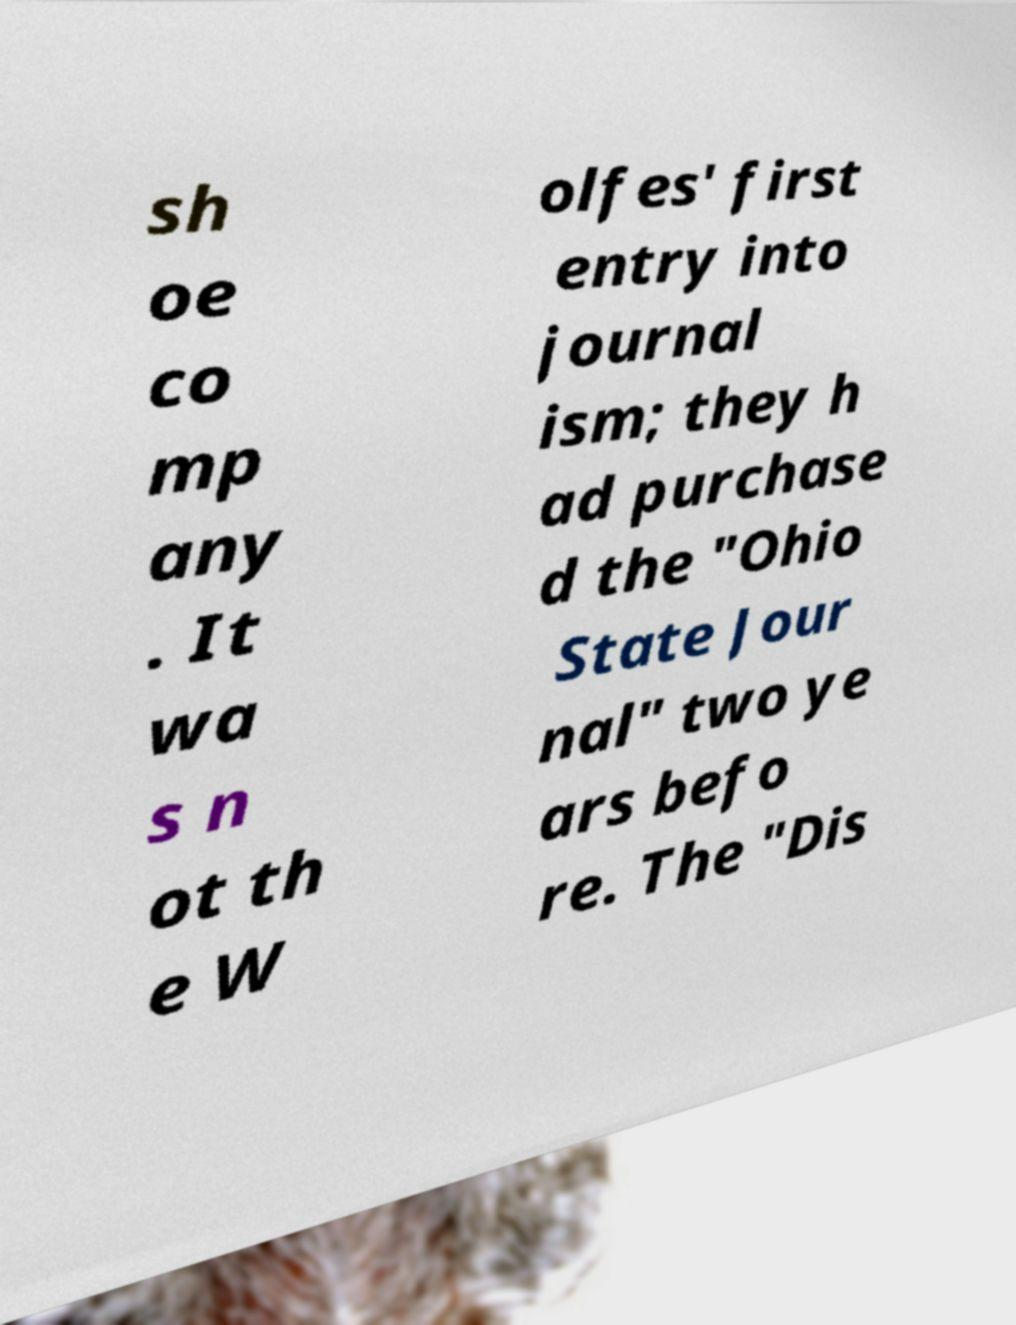Can you read and provide the text displayed in the image?This photo seems to have some interesting text. Can you extract and type it out for me? sh oe co mp any . It wa s n ot th e W olfes' first entry into journal ism; they h ad purchase d the "Ohio State Jour nal" two ye ars befo re. The "Dis 